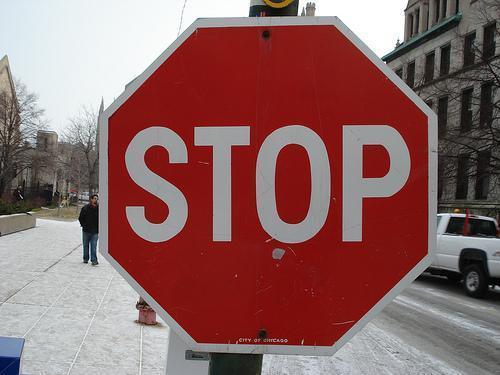How many stop signs are there?
Give a very brief answer. 1. 